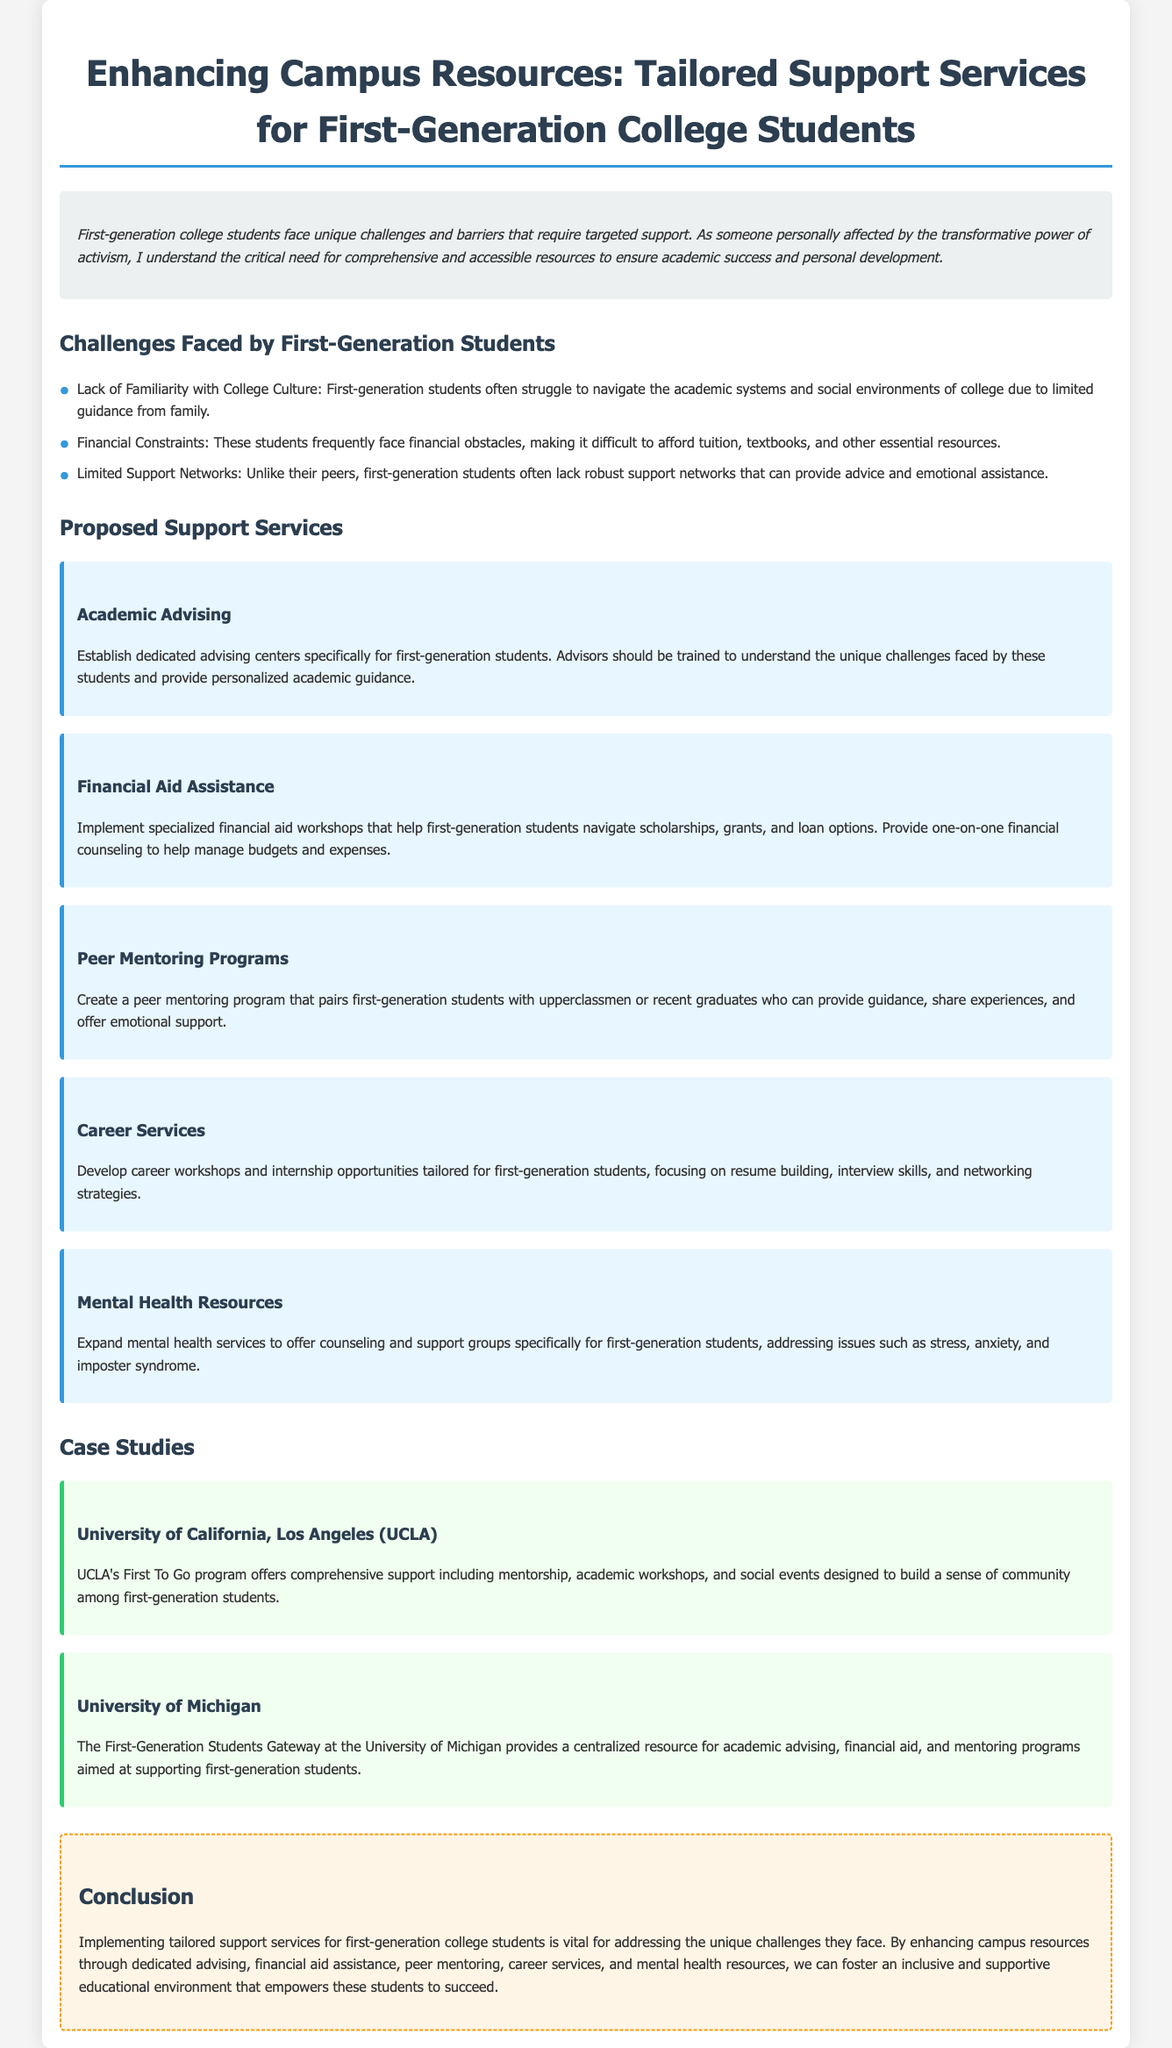What are the unique challenges faced by first-generation college students? The document lists challenges including lack of familiarity with college culture, financial constraints, and limited support networks.
Answer: Lack of familiarity with college culture, financial constraints, limited support networks How many proposed support services are mentioned in the document? The document lists five proposed support services aimed at helping first-generation college students.
Answer: Five What is one of the case studies mentioned? The document provides case studies from UCLA and the University of Michigan as examples of support for first-generation students.
Answer: University of California, Los Angeles (UCLA) What type of program does UCLA offer for first-generation students? The case study highlights UCLA’s First To Go program, which offers comprehensive support including mentorship and academic workshops.
Answer: First To Go program What is a proposed service for addressing financial issues faced by first-generation students? The document mentions implementing specialized financial aid workshops to help these students navigate financial assistance.
Answer: Financial aid assistance What mental health issue do the proposed resources aim to address? The document notes that services will focus on issues such as stress and anxiety for first-generation students.
Answer: Stress, anxiety Which proposed service focuses on career development? The document specifically proposes developing career workshops tailored for first-generation students to aid in their professional skills.
Answer: Career Services What color scheme is used in the case studies section? The case studies section has a background color described as light green in the document.
Answer: Light green What is the primary goal of enhancing campus resources according to the conclusion? The conclusion emphasizes the need for tailored support services to empower first-generation students to succeed academically and personally.
Answer: Empower first-generation students to succeed 